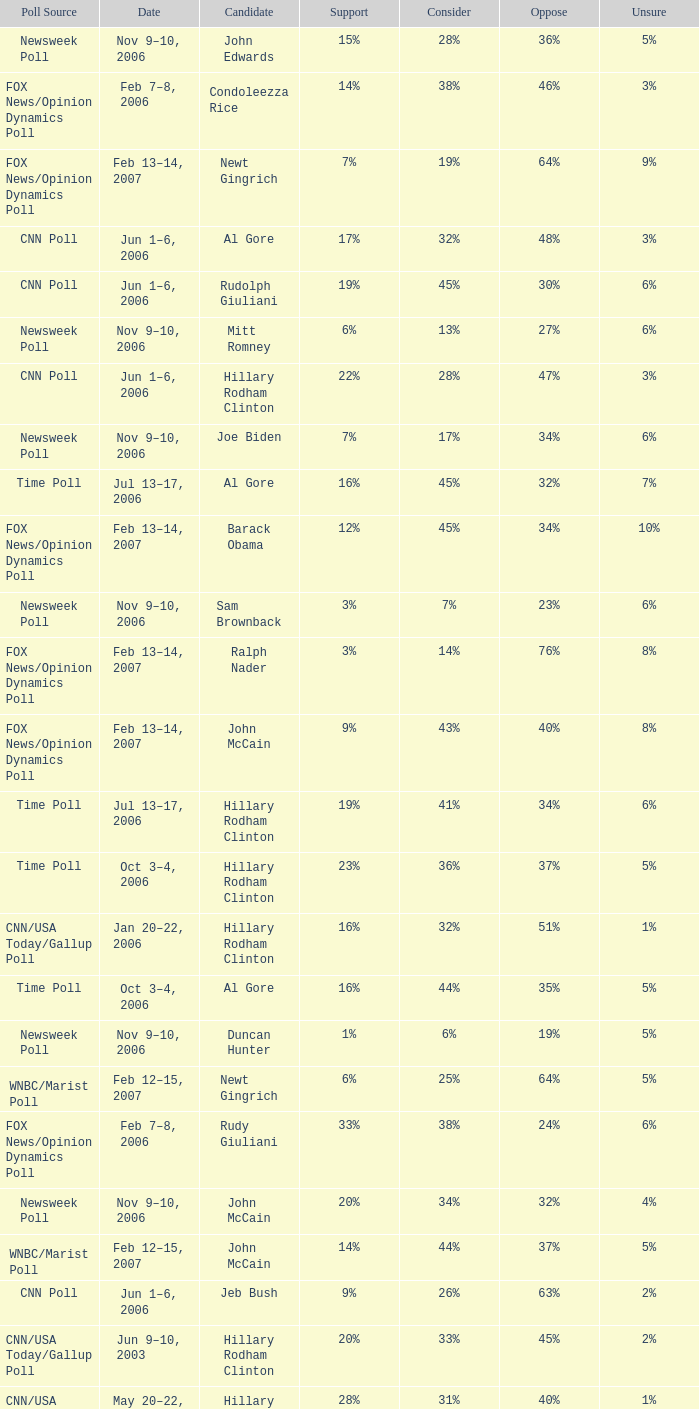What percentage of people were opposed to the candidate based on the Time Poll poll that showed 6% of people were unsure? 34%. 